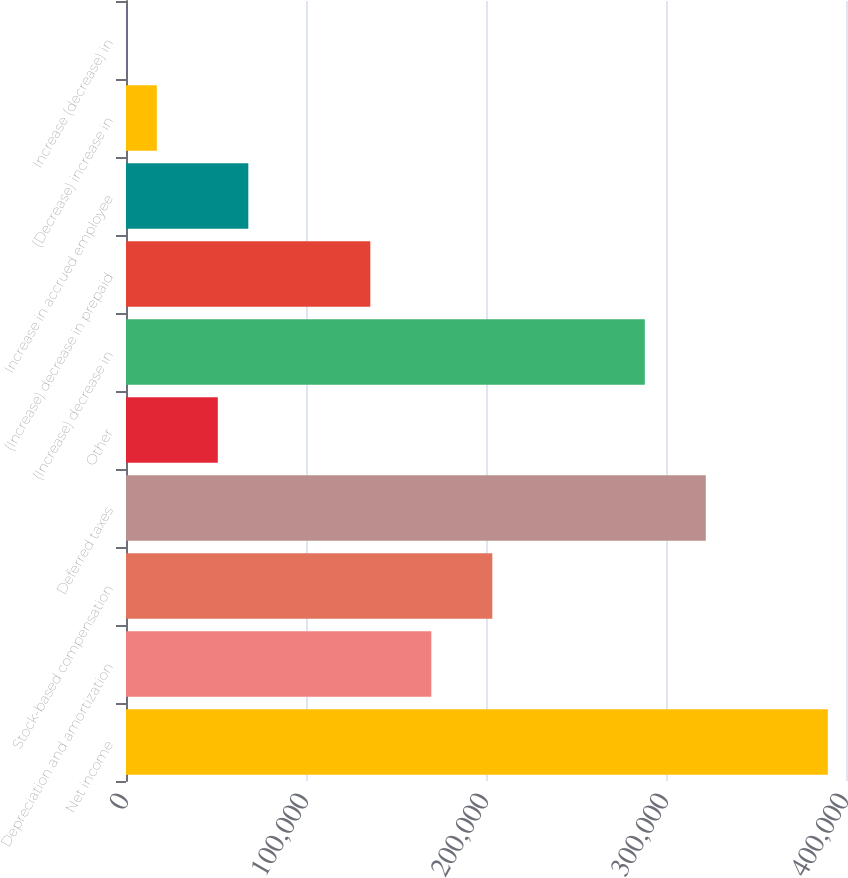Convert chart to OTSL. <chart><loc_0><loc_0><loc_500><loc_500><bar_chart><fcel>Net income<fcel>Depreciation and amortization<fcel>Stock-based compensation<fcel>Deferred taxes<fcel>Other<fcel>(Increase) decrease in<fcel>(Increase) decrease in prepaid<fcel>Increase in accrued employee<fcel>(Decrease) increase in<fcel>Increase (decrease) in<nl><fcel>389895<fcel>169620<fcel>203508<fcel>322118<fcel>51010.6<fcel>288229<fcel>135732<fcel>67954.8<fcel>17122.2<fcel>178<nl></chart> 